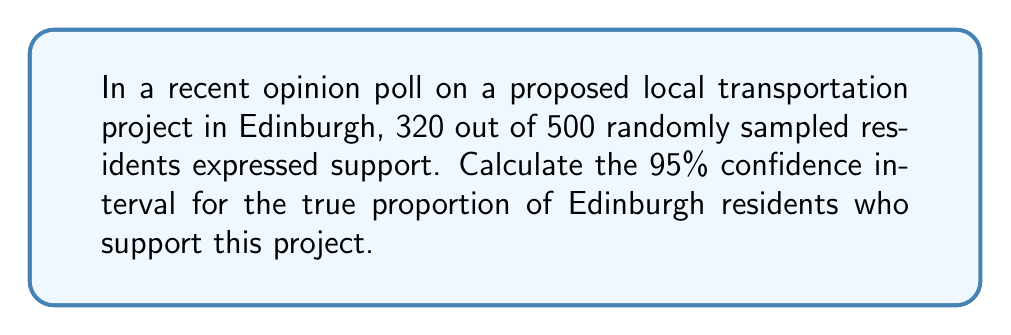Provide a solution to this math problem. To calculate the 95% confidence interval for a proportion, we'll use the formula:

$$\hat{p} \pm z \sqrt{\frac{\hat{p}(1-\hat{p})}{n}}$$

Where:
$\hat{p}$ = sample proportion
$z$ = z-score for desired confidence level (1.96 for 95% confidence)
$n$ = sample size

Step 1: Calculate the sample proportion $\hat{p}$
$$\hat{p} = \frac{320}{500} = 0.64$$

Step 2: Calculate the standard error
$$SE = \sqrt{\frac{\hat{p}(1-\hat{p})}{n}} = \sqrt{\frac{0.64(1-0.64)}{500}} = 0.0214$$

Step 3: Calculate the margin of error
$$ME = z \times SE = 1.96 \times 0.0214 = 0.042$$

Step 4: Calculate the confidence interval
Lower bound: $0.64 - 0.042 = 0.598$
Upper bound: $0.64 + 0.042 = 0.682$

Therefore, the 95% confidence interval is (0.598, 0.682) or (59.8%, 68.2%).
Answer: (59.8%, 68.2%) 